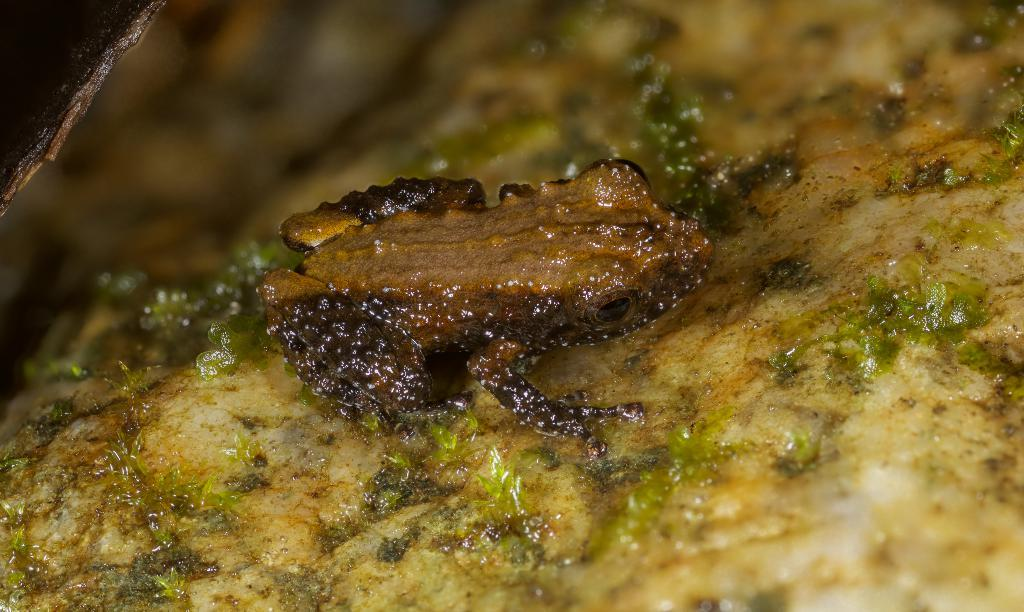What type of animal is in the image? There is a frog in the image. Can you describe the color of the frog? The frog is brown in color. What type of clothing is the judge wearing in the image? There is no judge present in the image; it features a brown frog. How many babies are visible in the image? There are no babies present in the image. 